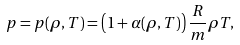<formula> <loc_0><loc_0><loc_500><loc_500>p = p ( \rho , T ) = \left ( 1 + \alpha ( \rho , T ) \right ) \frac { R } { m } \rho T ,</formula> 